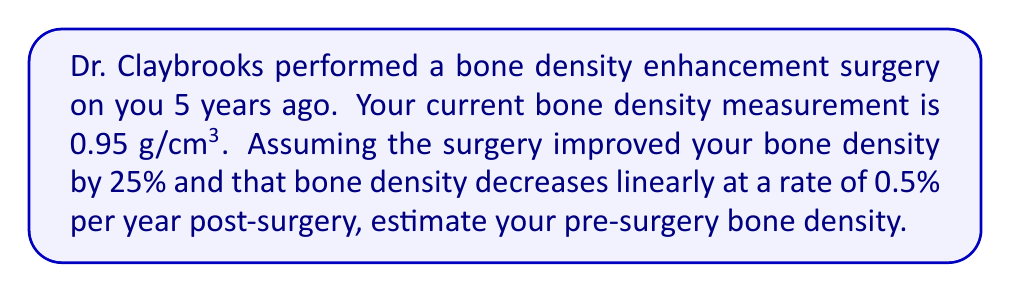Solve this math problem. Let's approach this step-by-step:

1) Let $x$ be the pre-surgery bone density in g/cm³.

2) After the surgery, the bone density increased by 25%:
   Post-surgery density = $x * 1.25$

3) Over 5 years, the bone density decreased linearly at 0.5% per year:
   Total decrease = $5 * 0.5\% = 2.5\%$
   Remaining factor after decrease = $1 - 0.025 = 0.975$

4) Current density = Post-surgery density * Remaining factor
   $0.95 = x * 1.25 * 0.975$

5) Solve for $x$:
   $$\begin{align}
   0.95 &= x * 1.25 * 0.975 \\
   0.95 &= x * 1.21875 \\
   x &= \frac{0.95}{1.21875} \\
   x &≈ 0.7794 \text{ g/cm³}
   \end{align}$$

Therefore, the estimated pre-surgery bone density is approximately 0.7794 g/cm³.
Answer: 0.7794 g/cm³ 